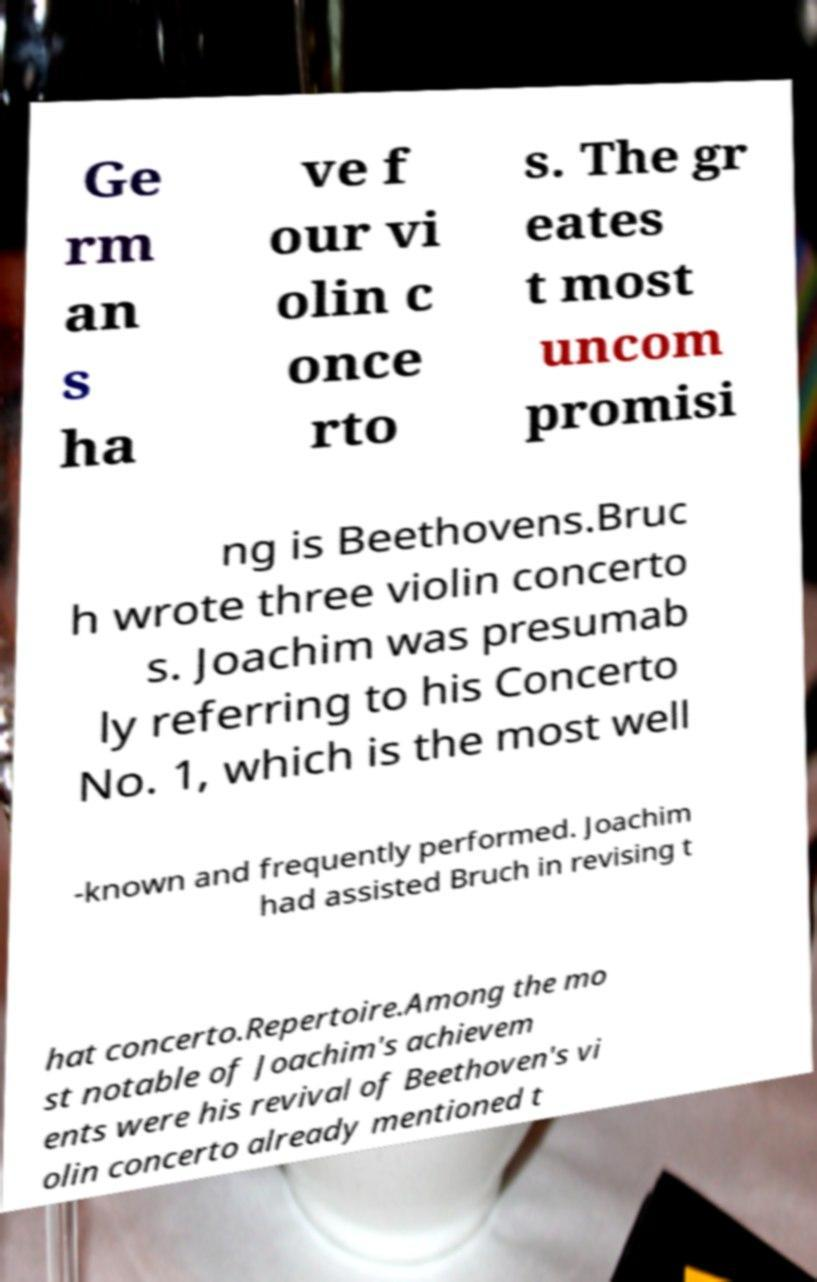Can you read and provide the text displayed in the image?This photo seems to have some interesting text. Can you extract and type it out for me? Ge rm an s ha ve f our vi olin c once rto s. The gr eates t most uncom promisi ng is Beethovens.Bruc h wrote three violin concerto s. Joachim was presumab ly referring to his Concerto No. 1, which is the most well -known and frequently performed. Joachim had assisted Bruch in revising t hat concerto.Repertoire.Among the mo st notable of Joachim's achievem ents were his revival of Beethoven's vi olin concerto already mentioned t 